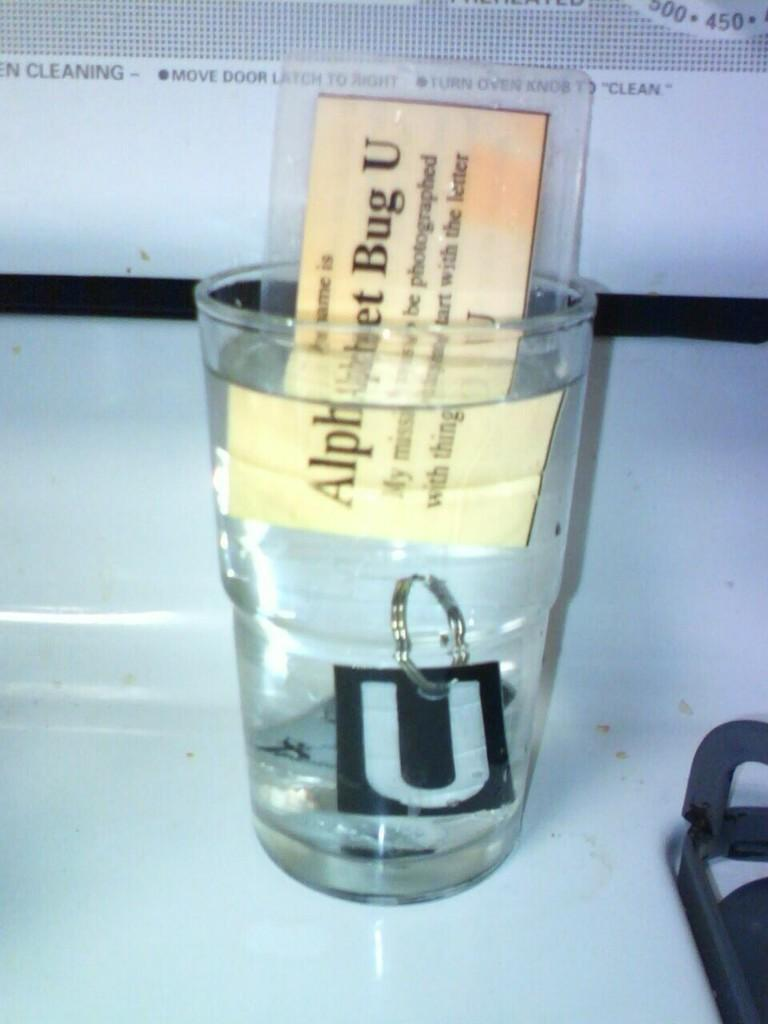<image>
Render a clear and concise summary of the photo. Someone has put a laminated card that says "Alphabet Bug U" into a glass of water. 